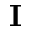Convert formula to latex. <formula><loc_0><loc_0><loc_500><loc_500>I</formula> 